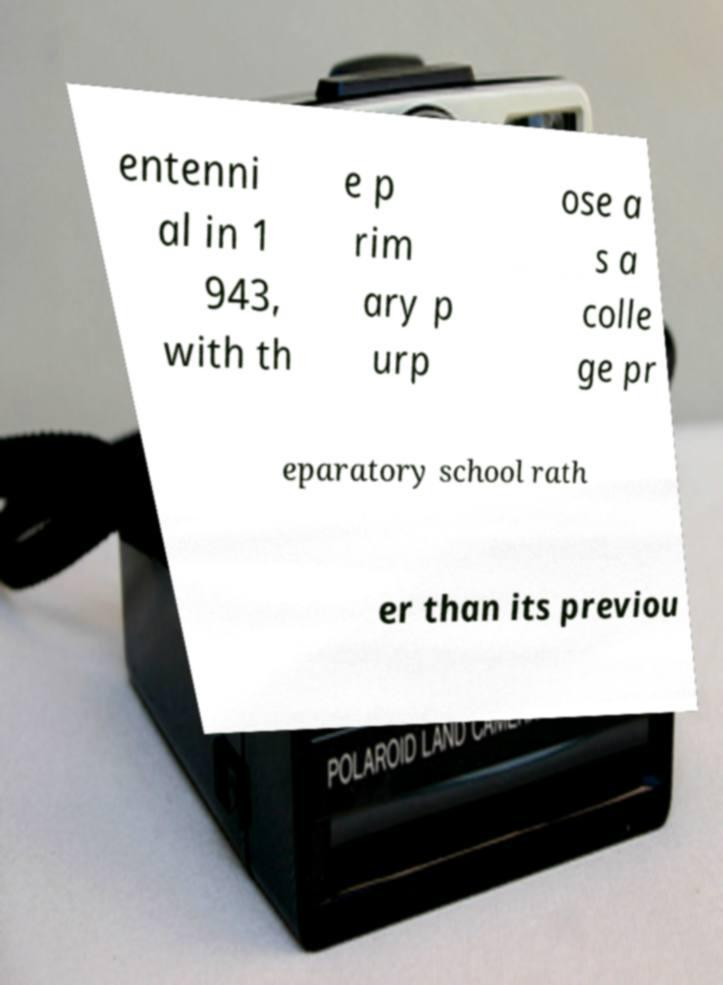What messages or text are displayed in this image? I need them in a readable, typed format. entenni al in 1 943, with th e p rim ary p urp ose a s a colle ge pr eparatory school rath er than its previou 